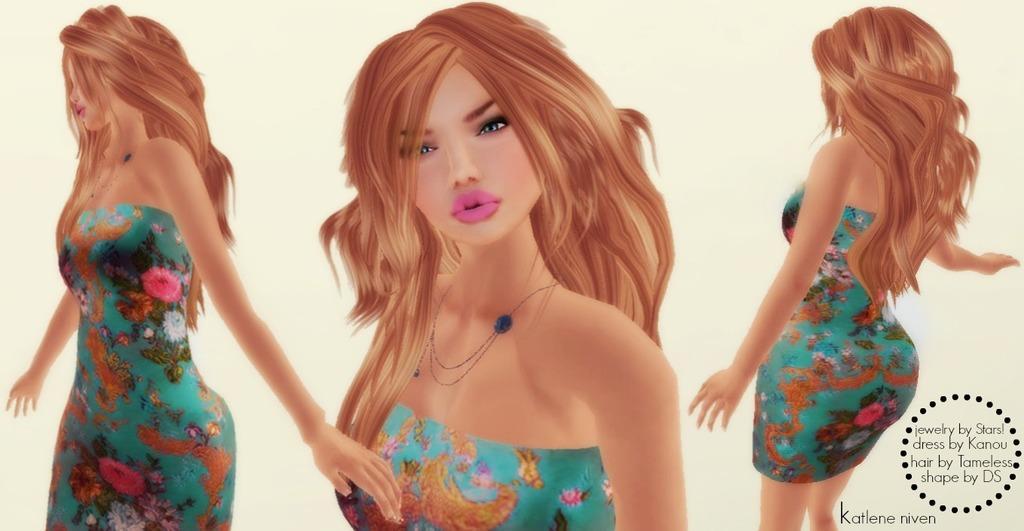Please provide a concise description of this image. This is an animated picture. In this picture there are images of a woman. On the right there is text. 